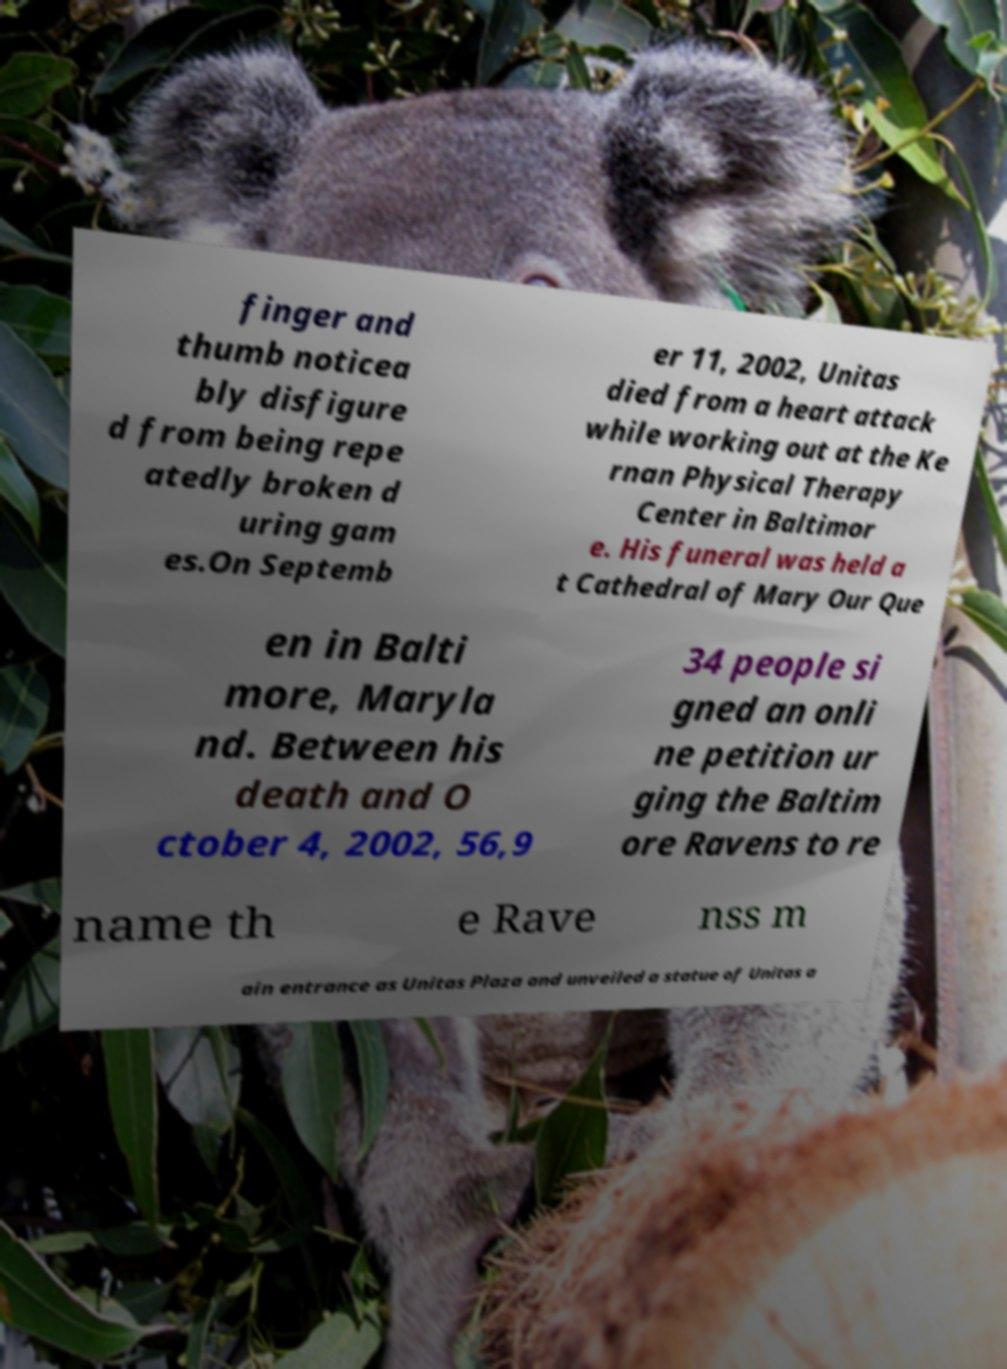Can you read and provide the text displayed in the image?This photo seems to have some interesting text. Can you extract and type it out for me? finger and thumb noticea bly disfigure d from being repe atedly broken d uring gam es.On Septemb er 11, 2002, Unitas died from a heart attack while working out at the Ke rnan Physical Therapy Center in Baltimor e. His funeral was held a t Cathedral of Mary Our Que en in Balti more, Maryla nd. Between his death and O ctober 4, 2002, 56,9 34 people si gned an onli ne petition ur ging the Baltim ore Ravens to re name th e Rave nss m ain entrance as Unitas Plaza and unveiled a statue of Unitas a 